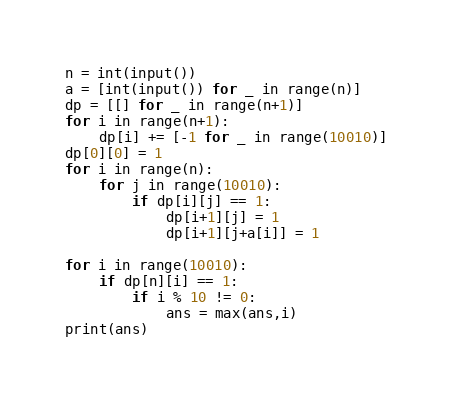<code> <loc_0><loc_0><loc_500><loc_500><_Python_>n = int(input())
a = [int(input()) for _ in range(n)]
dp = [[] for _ in range(n+1)]
for i in range(n+1):
    dp[i] += [-1 for _ in range(10010)]
dp[0][0] = 1
for i in range(n):
    for j in range(10010):
        if dp[i][j] == 1:
            dp[i+1][j] = 1
            dp[i+1][j+a[i]] = 1

for i in range(10010):
    if dp[n][i] == 1:
        if i % 10 != 0:
            ans = max(ans,i)
print(ans)</code> 